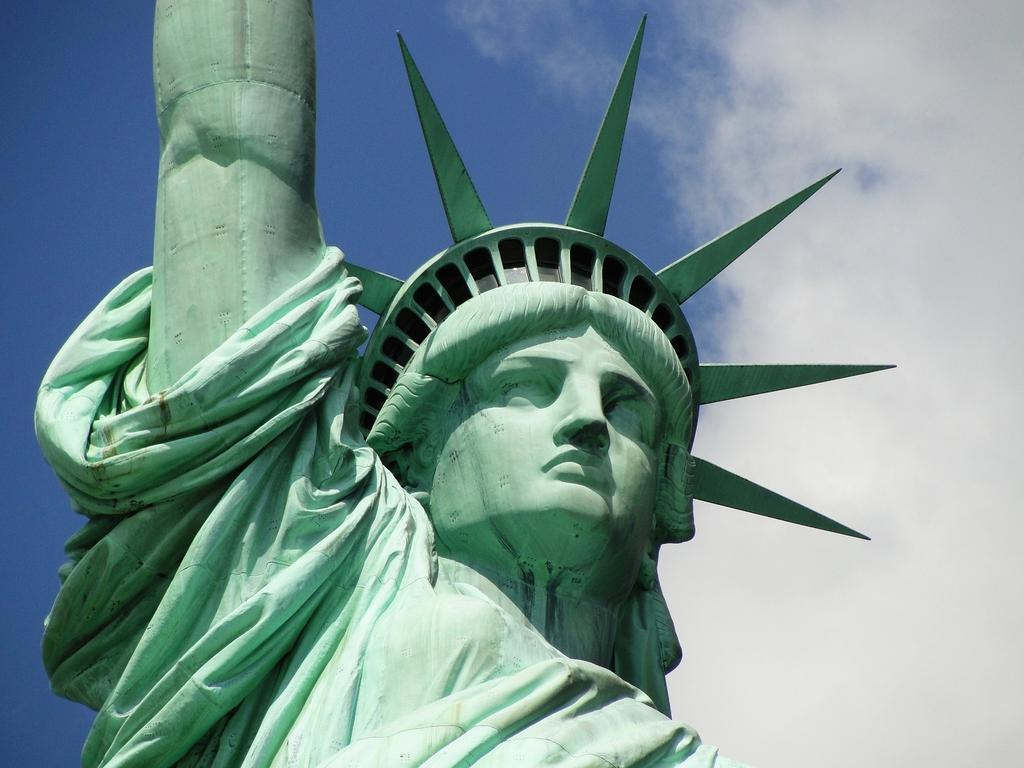What famous landmark can be seen in the image? The Statue of Liberty is present in the image. What can be seen in the background of the image? There are clouds in the background of the image. What is the color of the sky in the image? The sky is blue in color. What type of stew is being served to the family in the image? There is no family or stew present in the image; it features the Statue of Liberty with clouds and a blue sky in the background. 